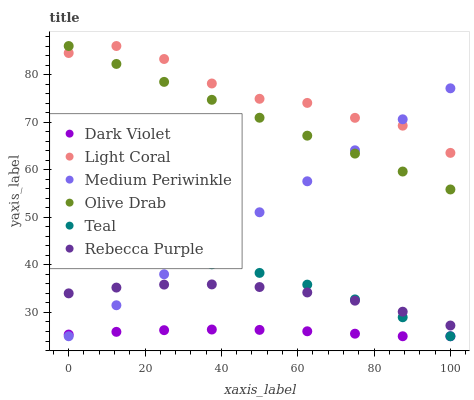Does Dark Violet have the minimum area under the curve?
Answer yes or no. Yes. Does Light Coral have the maximum area under the curve?
Answer yes or no. Yes. Does Light Coral have the minimum area under the curve?
Answer yes or no. No. Does Dark Violet have the maximum area under the curve?
Answer yes or no. No. Is Medium Periwinkle the smoothest?
Answer yes or no. Yes. Is Light Coral the roughest?
Answer yes or no. Yes. Is Dark Violet the smoothest?
Answer yes or no. No. Is Dark Violet the roughest?
Answer yes or no. No. Does Medium Periwinkle have the lowest value?
Answer yes or no. Yes. Does Light Coral have the lowest value?
Answer yes or no. No. Does Olive Drab have the highest value?
Answer yes or no. Yes. Does Dark Violet have the highest value?
Answer yes or no. No. Is Teal less than Light Coral?
Answer yes or no. Yes. Is Olive Drab greater than Rebecca Purple?
Answer yes or no. Yes. Does Medium Periwinkle intersect Teal?
Answer yes or no. Yes. Is Medium Periwinkle less than Teal?
Answer yes or no. No. Is Medium Periwinkle greater than Teal?
Answer yes or no. No. Does Teal intersect Light Coral?
Answer yes or no. No. 